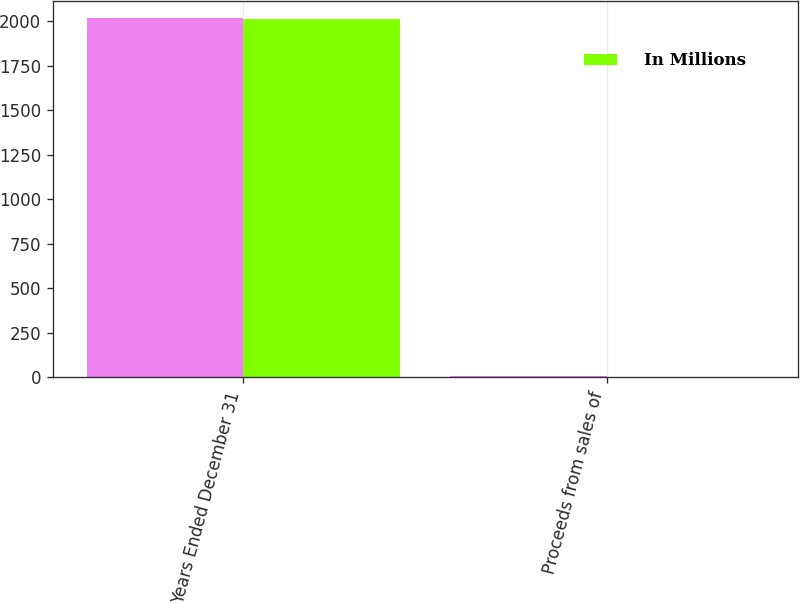Convert chart. <chart><loc_0><loc_0><loc_500><loc_500><stacked_bar_chart><ecel><fcel>Years Ended December 31<fcel>Proceeds from sales of<nl><fcel>nan<fcel>2014<fcel>8<nl><fcel>In Millions<fcel>2013<fcel>3<nl></chart> 